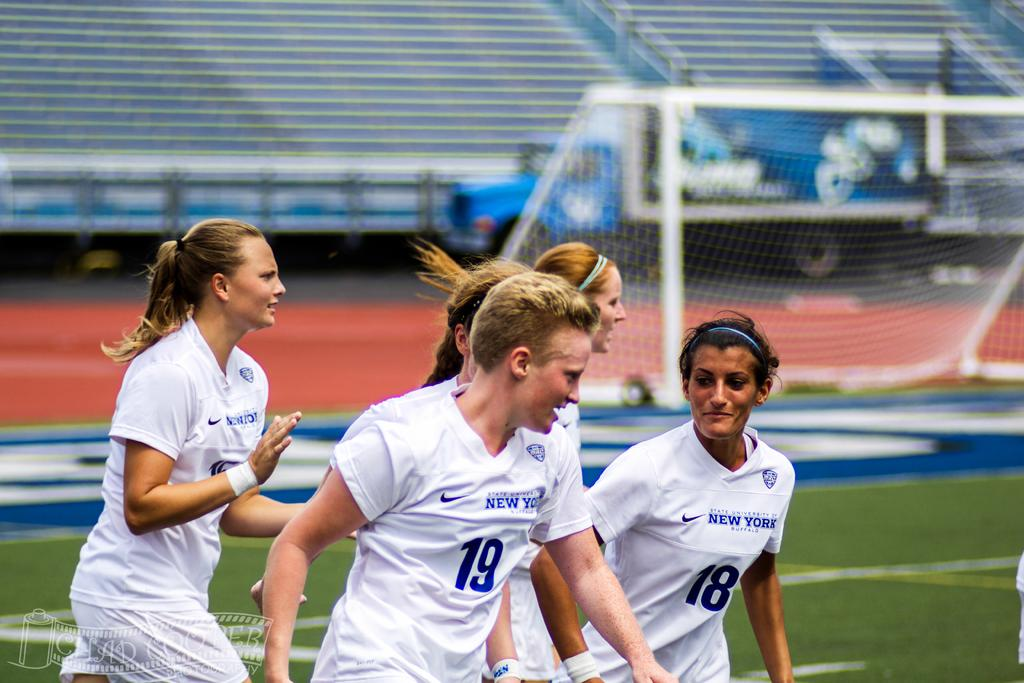What is the man in the image doing? The man is running in the image. What is the man wearing while running? The man is wearing a white dress. Are there any other people running in the image? Yes, there is a group of girls running in the image. What are the girls wearing while running? The girls are wearing white dresses. What can be seen on the right side of the image? There is a net on the right side of the image. What invention is the man holding in his hand while running? There is no invention visible in the man's hand in the image. What type of pen can be seen being used by the girls while running? There are no pens visible in the image; the girls are wearing white dresses and running. 